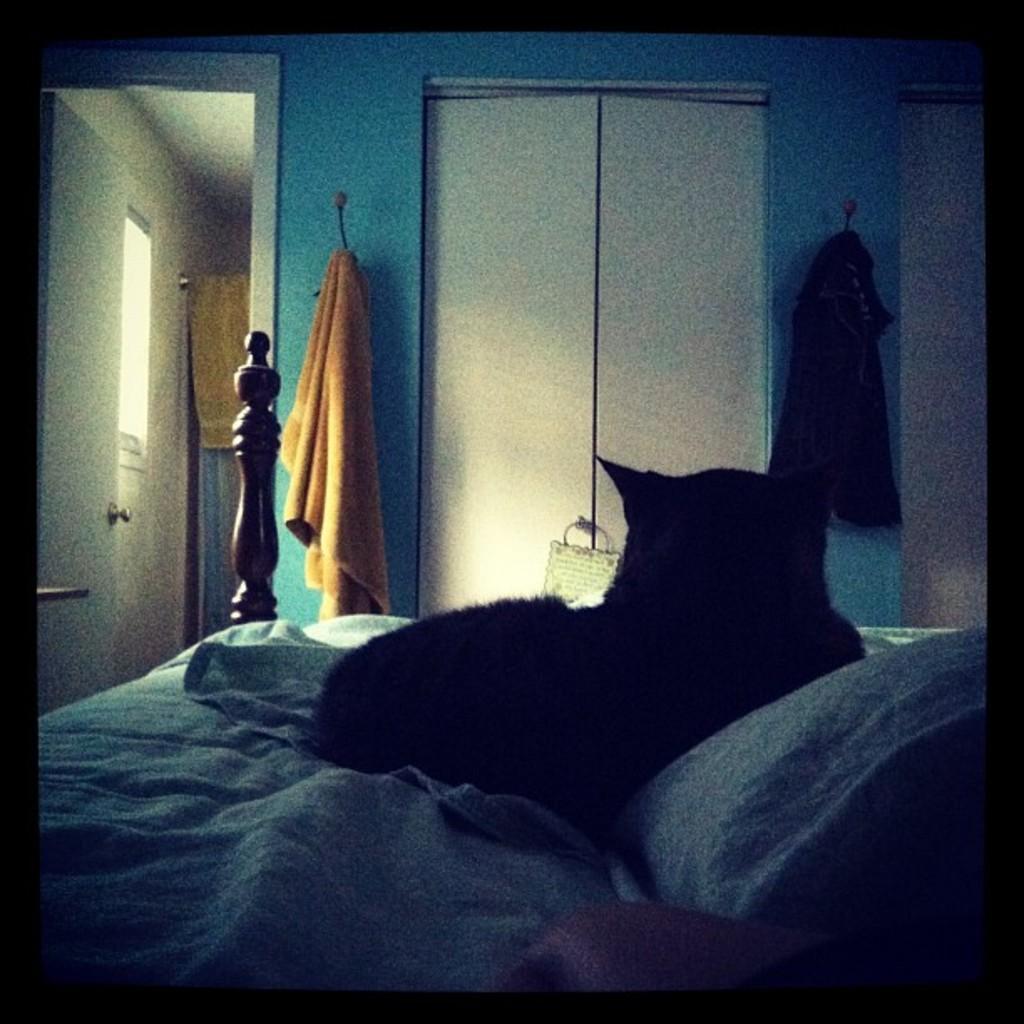Please provide a concise description of this image. This picture is inside of the room. There is a cat laying on the bed. At the back there is a door, there is a towel hanging on the hanger. 